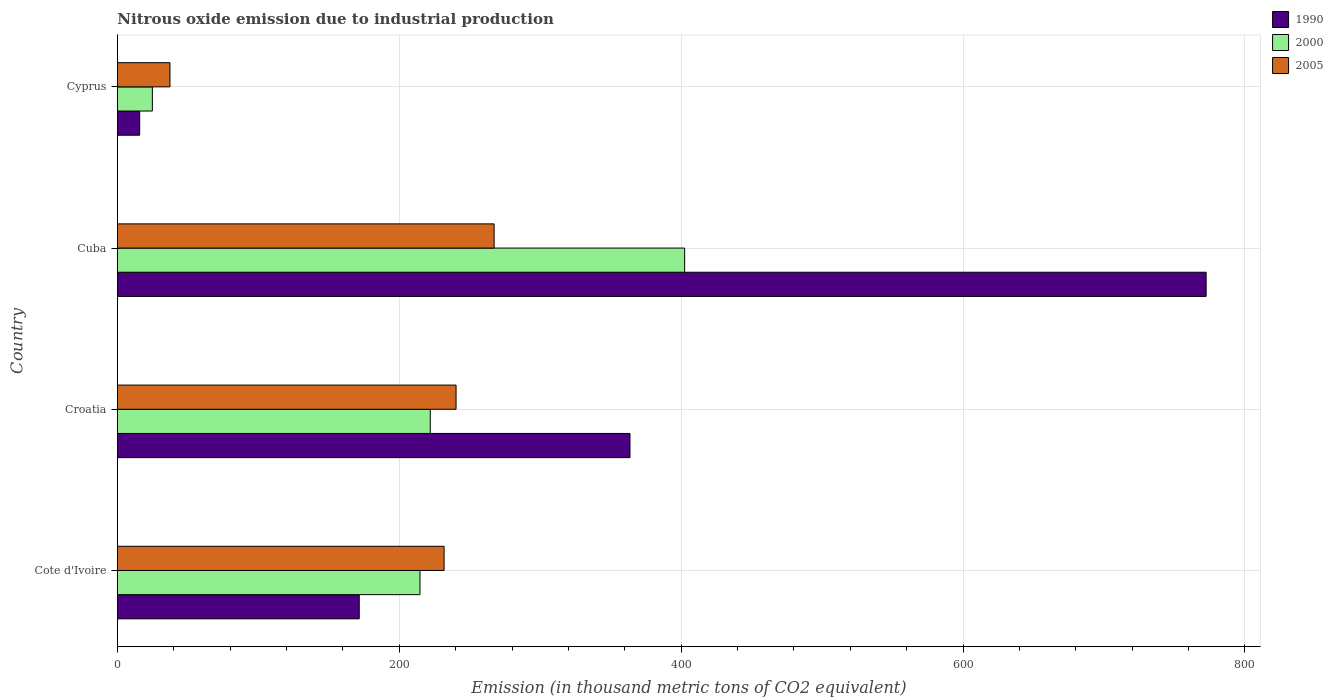How many bars are there on the 4th tick from the top?
Your response must be concise. 3. How many bars are there on the 3rd tick from the bottom?
Give a very brief answer. 3. What is the label of the 4th group of bars from the top?
Ensure brevity in your answer.  Cote d'Ivoire. What is the amount of nitrous oxide emitted in 2005 in Cyprus?
Offer a very short reply. 37.3. Across all countries, what is the maximum amount of nitrous oxide emitted in 2000?
Offer a terse response. 402.5. Across all countries, what is the minimum amount of nitrous oxide emitted in 1990?
Your answer should be very brief. 15.8. In which country was the amount of nitrous oxide emitted in 2005 maximum?
Ensure brevity in your answer.  Cuba. In which country was the amount of nitrous oxide emitted in 2000 minimum?
Ensure brevity in your answer.  Cyprus. What is the total amount of nitrous oxide emitted in 2000 in the graph?
Provide a succinct answer. 864. What is the difference between the amount of nitrous oxide emitted in 2000 in Cote d'Ivoire and that in Croatia?
Your answer should be compact. -7.3. What is the difference between the amount of nitrous oxide emitted in 1990 in Cuba and the amount of nitrous oxide emitted in 2005 in Cyprus?
Keep it short and to the point. 735.2. What is the average amount of nitrous oxide emitted in 1990 per country?
Keep it short and to the point. 330.9. What is the difference between the amount of nitrous oxide emitted in 2000 and amount of nitrous oxide emitted in 1990 in Cuba?
Keep it short and to the point. -370. What is the ratio of the amount of nitrous oxide emitted in 2000 in Croatia to that in Cuba?
Your answer should be compact. 0.55. What is the difference between the highest and the second highest amount of nitrous oxide emitted in 2000?
Provide a short and direct response. 180.5. What is the difference between the highest and the lowest amount of nitrous oxide emitted in 2005?
Give a very brief answer. 230. Is the sum of the amount of nitrous oxide emitted in 2005 in Croatia and Cuba greater than the maximum amount of nitrous oxide emitted in 1990 across all countries?
Offer a very short reply. No. What does the 2nd bar from the top in Croatia represents?
Provide a succinct answer. 2000. Are all the bars in the graph horizontal?
Your answer should be compact. Yes. Are the values on the major ticks of X-axis written in scientific E-notation?
Keep it short and to the point. No. Does the graph contain grids?
Make the answer very short. Yes. Where does the legend appear in the graph?
Offer a very short reply. Top right. How are the legend labels stacked?
Provide a succinct answer. Vertical. What is the title of the graph?
Give a very brief answer. Nitrous oxide emission due to industrial production. Does "1965" appear as one of the legend labels in the graph?
Offer a terse response. No. What is the label or title of the X-axis?
Offer a very short reply. Emission (in thousand metric tons of CO2 equivalent). What is the Emission (in thousand metric tons of CO2 equivalent) of 1990 in Cote d'Ivoire?
Offer a very short reply. 171.6. What is the Emission (in thousand metric tons of CO2 equivalent) of 2000 in Cote d'Ivoire?
Your response must be concise. 214.7. What is the Emission (in thousand metric tons of CO2 equivalent) of 2005 in Cote d'Ivoire?
Provide a succinct answer. 231.8. What is the Emission (in thousand metric tons of CO2 equivalent) in 1990 in Croatia?
Make the answer very short. 363.7. What is the Emission (in thousand metric tons of CO2 equivalent) of 2000 in Croatia?
Give a very brief answer. 222. What is the Emission (in thousand metric tons of CO2 equivalent) in 2005 in Croatia?
Make the answer very short. 240.3. What is the Emission (in thousand metric tons of CO2 equivalent) of 1990 in Cuba?
Make the answer very short. 772.5. What is the Emission (in thousand metric tons of CO2 equivalent) in 2000 in Cuba?
Offer a terse response. 402.5. What is the Emission (in thousand metric tons of CO2 equivalent) in 2005 in Cuba?
Your answer should be compact. 267.3. What is the Emission (in thousand metric tons of CO2 equivalent) in 1990 in Cyprus?
Provide a succinct answer. 15.8. What is the Emission (in thousand metric tons of CO2 equivalent) of 2000 in Cyprus?
Provide a short and direct response. 24.8. What is the Emission (in thousand metric tons of CO2 equivalent) in 2005 in Cyprus?
Offer a terse response. 37.3. Across all countries, what is the maximum Emission (in thousand metric tons of CO2 equivalent) of 1990?
Your answer should be very brief. 772.5. Across all countries, what is the maximum Emission (in thousand metric tons of CO2 equivalent) in 2000?
Offer a terse response. 402.5. Across all countries, what is the maximum Emission (in thousand metric tons of CO2 equivalent) of 2005?
Make the answer very short. 267.3. Across all countries, what is the minimum Emission (in thousand metric tons of CO2 equivalent) in 2000?
Keep it short and to the point. 24.8. Across all countries, what is the minimum Emission (in thousand metric tons of CO2 equivalent) in 2005?
Give a very brief answer. 37.3. What is the total Emission (in thousand metric tons of CO2 equivalent) in 1990 in the graph?
Make the answer very short. 1323.6. What is the total Emission (in thousand metric tons of CO2 equivalent) in 2000 in the graph?
Ensure brevity in your answer.  864. What is the total Emission (in thousand metric tons of CO2 equivalent) of 2005 in the graph?
Make the answer very short. 776.7. What is the difference between the Emission (in thousand metric tons of CO2 equivalent) in 1990 in Cote d'Ivoire and that in Croatia?
Your answer should be very brief. -192.1. What is the difference between the Emission (in thousand metric tons of CO2 equivalent) of 2000 in Cote d'Ivoire and that in Croatia?
Ensure brevity in your answer.  -7.3. What is the difference between the Emission (in thousand metric tons of CO2 equivalent) in 1990 in Cote d'Ivoire and that in Cuba?
Keep it short and to the point. -600.9. What is the difference between the Emission (in thousand metric tons of CO2 equivalent) in 2000 in Cote d'Ivoire and that in Cuba?
Offer a terse response. -187.8. What is the difference between the Emission (in thousand metric tons of CO2 equivalent) in 2005 in Cote d'Ivoire and that in Cuba?
Provide a short and direct response. -35.5. What is the difference between the Emission (in thousand metric tons of CO2 equivalent) in 1990 in Cote d'Ivoire and that in Cyprus?
Make the answer very short. 155.8. What is the difference between the Emission (in thousand metric tons of CO2 equivalent) of 2000 in Cote d'Ivoire and that in Cyprus?
Your answer should be very brief. 189.9. What is the difference between the Emission (in thousand metric tons of CO2 equivalent) in 2005 in Cote d'Ivoire and that in Cyprus?
Give a very brief answer. 194.5. What is the difference between the Emission (in thousand metric tons of CO2 equivalent) of 1990 in Croatia and that in Cuba?
Offer a very short reply. -408.8. What is the difference between the Emission (in thousand metric tons of CO2 equivalent) of 2000 in Croatia and that in Cuba?
Offer a terse response. -180.5. What is the difference between the Emission (in thousand metric tons of CO2 equivalent) in 1990 in Croatia and that in Cyprus?
Provide a succinct answer. 347.9. What is the difference between the Emission (in thousand metric tons of CO2 equivalent) of 2000 in Croatia and that in Cyprus?
Give a very brief answer. 197.2. What is the difference between the Emission (in thousand metric tons of CO2 equivalent) in 2005 in Croatia and that in Cyprus?
Provide a succinct answer. 203. What is the difference between the Emission (in thousand metric tons of CO2 equivalent) in 1990 in Cuba and that in Cyprus?
Your answer should be compact. 756.7. What is the difference between the Emission (in thousand metric tons of CO2 equivalent) of 2000 in Cuba and that in Cyprus?
Provide a short and direct response. 377.7. What is the difference between the Emission (in thousand metric tons of CO2 equivalent) of 2005 in Cuba and that in Cyprus?
Keep it short and to the point. 230. What is the difference between the Emission (in thousand metric tons of CO2 equivalent) of 1990 in Cote d'Ivoire and the Emission (in thousand metric tons of CO2 equivalent) of 2000 in Croatia?
Your response must be concise. -50.4. What is the difference between the Emission (in thousand metric tons of CO2 equivalent) in 1990 in Cote d'Ivoire and the Emission (in thousand metric tons of CO2 equivalent) in 2005 in Croatia?
Keep it short and to the point. -68.7. What is the difference between the Emission (in thousand metric tons of CO2 equivalent) of 2000 in Cote d'Ivoire and the Emission (in thousand metric tons of CO2 equivalent) of 2005 in Croatia?
Your response must be concise. -25.6. What is the difference between the Emission (in thousand metric tons of CO2 equivalent) of 1990 in Cote d'Ivoire and the Emission (in thousand metric tons of CO2 equivalent) of 2000 in Cuba?
Your answer should be very brief. -230.9. What is the difference between the Emission (in thousand metric tons of CO2 equivalent) in 1990 in Cote d'Ivoire and the Emission (in thousand metric tons of CO2 equivalent) in 2005 in Cuba?
Your answer should be compact. -95.7. What is the difference between the Emission (in thousand metric tons of CO2 equivalent) of 2000 in Cote d'Ivoire and the Emission (in thousand metric tons of CO2 equivalent) of 2005 in Cuba?
Ensure brevity in your answer.  -52.6. What is the difference between the Emission (in thousand metric tons of CO2 equivalent) in 1990 in Cote d'Ivoire and the Emission (in thousand metric tons of CO2 equivalent) in 2000 in Cyprus?
Ensure brevity in your answer.  146.8. What is the difference between the Emission (in thousand metric tons of CO2 equivalent) of 1990 in Cote d'Ivoire and the Emission (in thousand metric tons of CO2 equivalent) of 2005 in Cyprus?
Your answer should be very brief. 134.3. What is the difference between the Emission (in thousand metric tons of CO2 equivalent) in 2000 in Cote d'Ivoire and the Emission (in thousand metric tons of CO2 equivalent) in 2005 in Cyprus?
Provide a succinct answer. 177.4. What is the difference between the Emission (in thousand metric tons of CO2 equivalent) in 1990 in Croatia and the Emission (in thousand metric tons of CO2 equivalent) in 2000 in Cuba?
Offer a terse response. -38.8. What is the difference between the Emission (in thousand metric tons of CO2 equivalent) of 1990 in Croatia and the Emission (in thousand metric tons of CO2 equivalent) of 2005 in Cuba?
Offer a very short reply. 96.4. What is the difference between the Emission (in thousand metric tons of CO2 equivalent) in 2000 in Croatia and the Emission (in thousand metric tons of CO2 equivalent) in 2005 in Cuba?
Your answer should be very brief. -45.3. What is the difference between the Emission (in thousand metric tons of CO2 equivalent) in 1990 in Croatia and the Emission (in thousand metric tons of CO2 equivalent) in 2000 in Cyprus?
Give a very brief answer. 338.9. What is the difference between the Emission (in thousand metric tons of CO2 equivalent) of 1990 in Croatia and the Emission (in thousand metric tons of CO2 equivalent) of 2005 in Cyprus?
Your answer should be compact. 326.4. What is the difference between the Emission (in thousand metric tons of CO2 equivalent) in 2000 in Croatia and the Emission (in thousand metric tons of CO2 equivalent) in 2005 in Cyprus?
Ensure brevity in your answer.  184.7. What is the difference between the Emission (in thousand metric tons of CO2 equivalent) in 1990 in Cuba and the Emission (in thousand metric tons of CO2 equivalent) in 2000 in Cyprus?
Offer a terse response. 747.7. What is the difference between the Emission (in thousand metric tons of CO2 equivalent) in 1990 in Cuba and the Emission (in thousand metric tons of CO2 equivalent) in 2005 in Cyprus?
Make the answer very short. 735.2. What is the difference between the Emission (in thousand metric tons of CO2 equivalent) in 2000 in Cuba and the Emission (in thousand metric tons of CO2 equivalent) in 2005 in Cyprus?
Your answer should be compact. 365.2. What is the average Emission (in thousand metric tons of CO2 equivalent) of 1990 per country?
Offer a terse response. 330.9. What is the average Emission (in thousand metric tons of CO2 equivalent) of 2000 per country?
Your answer should be compact. 216. What is the average Emission (in thousand metric tons of CO2 equivalent) of 2005 per country?
Keep it short and to the point. 194.18. What is the difference between the Emission (in thousand metric tons of CO2 equivalent) of 1990 and Emission (in thousand metric tons of CO2 equivalent) of 2000 in Cote d'Ivoire?
Your answer should be compact. -43.1. What is the difference between the Emission (in thousand metric tons of CO2 equivalent) of 1990 and Emission (in thousand metric tons of CO2 equivalent) of 2005 in Cote d'Ivoire?
Your answer should be very brief. -60.2. What is the difference between the Emission (in thousand metric tons of CO2 equivalent) of 2000 and Emission (in thousand metric tons of CO2 equivalent) of 2005 in Cote d'Ivoire?
Your answer should be very brief. -17.1. What is the difference between the Emission (in thousand metric tons of CO2 equivalent) of 1990 and Emission (in thousand metric tons of CO2 equivalent) of 2000 in Croatia?
Provide a short and direct response. 141.7. What is the difference between the Emission (in thousand metric tons of CO2 equivalent) of 1990 and Emission (in thousand metric tons of CO2 equivalent) of 2005 in Croatia?
Make the answer very short. 123.4. What is the difference between the Emission (in thousand metric tons of CO2 equivalent) in 2000 and Emission (in thousand metric tons of CO2 equivalent) in 2005 in Croatia?
Your answer should be very brief. -18.3. What is the difference between the Emission (in thousand metric tons of CO2 equivalent) in 1990 and Emission (in thousand metric tons of CO2 equivalent) in 2000 in Cuba?
Offer a very short reply. 370. What is the difference between the Emission (in thousand metric tons of CO2 equivalent) of 1990 and Emission (in thousand metric tons of CO2 equivalent) of 2005 in Cuba?
Your answer should be very brief. 505.2. What is the difference between the Emission (in thousand metric tons of CO2 equivalent) in 2000 and Emission (in thousand metric tons of CO2 equivalent) in 2005 in Cuba?
Offer a terse response. 135.2. What is the difference between the Emission (in thousand metric tons of CO2 equivalent) of 1990 and Emission (in thousand metric tons of CO2 equivalent) of 2005 in Cyprus?
Give a very brief answer. -21.5. What is the ratio of the Emission (in thousand metric tons of CO2 equivalent) of 1990 in Cote d'Ivoire to that in Croatia?
Make the answer very short. 0.47. What is the ratio of the Emission (in thousand metric tons of CO2 equivalent) in 2000 in Cote d'Ivoire to that in Croatia?
Keep it short and to the point. 0.97. What is the ratio of the Emission (in thousand metric tons of CO2 equivalent) of 2005 in Cote d'Ivoire to that in Croatia?
Offer a very short reply. 0.96. What is the ratio of the Emission (in thousand metric tons of CO2 equivalent) of 1990 in Cote d'Ivoire to that in Cuba?
Ensure brevity in your answer.  0.22. What is the ratio of the Emission (in thousand metric tons of CO2 equivalent) of 2000 in Cote d'Ivoire to that in Cuba?
Provide a short and direct response. 0.53. What is the ratio of the Emission (in thousand metric tons of CO2 equivalent) in 2005 in Cote d'Ivoire to that in Cuba?
Your answer should be compact. 0.87. What is the ratio of the Emission (in thousand metric tons of CO2 equivalent) in 1990 in Cote d'Ivoire to that in Cyprus?
Ensure brevity in your answer.  10.86. What is the ratio of the Emission (in thousand metric tons of CO2 equivalent) of 2000 in Cote d'Ivoire to that in Cyprus?
Provide a short and direct response. 8.66. What is the ratio of the Emission (in thousand metric tons of CO2 equivalent) in 2005 in Cote d'Ivoire to that in Cyprus?
Your answer should be compact. 6.21. What is the ratio of the Emission (in thousand metric tons of CO2 equivalent) of 1990 in Croatia to that in Cuba?
Keep it short and to the point. 0.47. What is the ratio of the Emission (in thousand metric tons of CO2 equivalent) in 2000 in Croatia to that in Cuba?
Offer a terse response. 0.55. What is the ratio of the Emission (in thousand metric tons of CO2 equivalent) of 2005 in Croatia to that in Cuba?
Provide a short and direct response. 0.9. What is the ratio of the Emission (in thousand metric tons of CO2 equivalent) of 1990 in Croatia to that in Cyprus?
Your answer should be compact. 23.02. What is the ratio of the Emission (in thousand metric tons of CO2 equivalent) of 2000 in Croatia to that in Cyprus?
Make the answer very short. 8.95. What is the ratio of the Emission (in thousand metric tons of CO2 equivalent) in 2005 in Croatia to that in Cyprus?
Keep it short and to the point. 6.44. What is the ratio of the Emission (in thousand metric tons of CO2 equivalent) in 1990 in Cuba to that in Cyprus?
Your response must be concise. 48.89. What is the ratio of the Emission (in thousand metric tons of CO2 equivalent) in 2000 in Cuba to that in Cyprus?
Provide a short and direct response. 16.23. What is the ratio of the Emission (in thousand metric tons of CO2 equivalent) of 2005 in Cuba to that in Cyprus?
Offer a very short reply. 7.17. What is the difference between the highest and the second highest Emission (in thousand metric tons of CO2 equivalent) of 1990?
Provide a short and direct response. 408.8. What is the difference between the highest and the second highest Emission (in thousand metric tons of CO2 equivalent) of 2000?
Your answer should be very brief. 180.5. What is the difference between the highest and the lowest Emission (in thousand metric tons of CO2 equivalent) of 1990?
Provide a short and direct response. 756.7. What is the difference between the highest and the lowest Emission (in thousand metric tons of CO2 equivalent) in 2000?
Your answer should be compact. 377.7. What is the difference between the highest and the lowest Emission (in thousand metric tons of CO2 equivalent) in 2005?
Give a very brief answer. 230. 